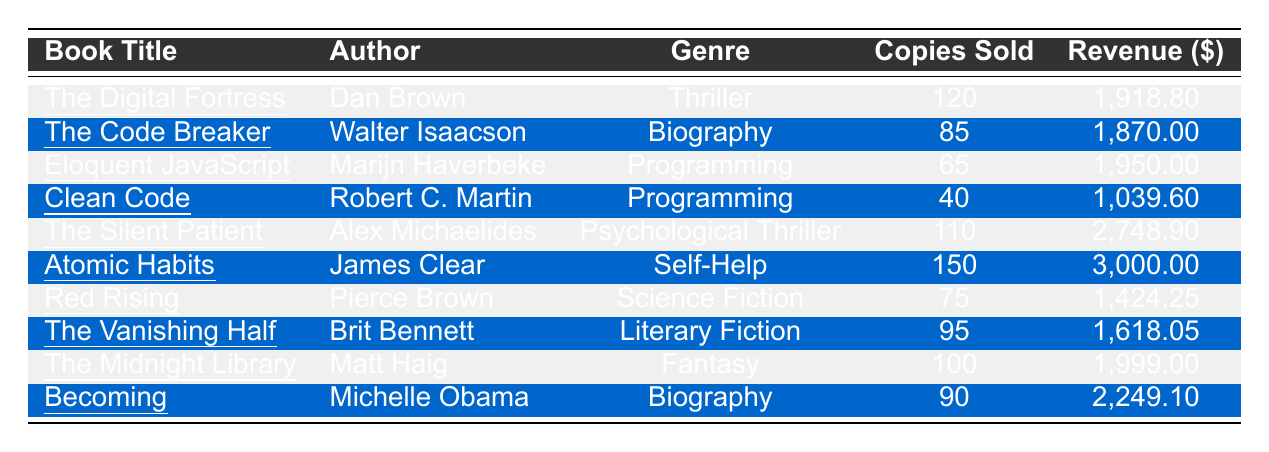What is the total revenue generated from "Atomic Habits"? The total revenue for "Atomic Habits" is listed directly in the table as $3,000.00.
Answer: 3,000.00 Which book sold the least number of copies? From the table, "Clean Code" sold 40 copies, which is the smallest number compared to the other titles.
Answer: Clean Code How many copies were sold in total for all books listed? To find the total copies sold, we need to sum the copies sold: 120 + 85 + 65 + 40 + 110 + 150 + 75 + 95 + 100 + 90 = 1030.
Answer: 1030 What is the average price per copy for all the books? We need to calculate the total revenue and the total copies sold first. Total revenue is $1,918.80 + $1,870.00 + $1,950.00 + $1,039.60 + $2,748.90 + $3,000.00 + $1,424.25 + $1,618.05 + $1,999.00 + $2,249.10 = $19,217.70. The average price is total revenue ($19,217.70) divided by total copies sold (1030) = $18.63 approximately.
Answer: 18.63 Is "Eloquent JavaScript" a part of the programming genre? Yes, the genre for "Eloquent JavaScript" is stated as programming in the table.
Answer: Yes What was the total revenue for books by Walter Isaacson? The only book by Walter Isaacson listed is "The Code Breaker" with a total revenue of $1,870.00.
Answer: 1,870.00 How many more copies were sold of "The Silent Patient" compared to "Clean Code"? "The Silent Patient" sold 110 copies and "Clean Code" sold 40 copies. The difference is 110 - 40 = 70 copies.
Answer: 70 Which genre had the highest total revenue? The total revenue for each genre needs to be summed up: "Thriller": $1,918.80, "Biography": $1,870.00 + $2,249.10 = $4,119.10, "Programming": $1,950.00 + $1,039.60 = $2,989.60, "Psychological Thriller": $2,748.90, "Self-Help": $3,000.00, "Science Fiction": $1,424.25, "Literary Fiction": $1,618.05, "Fantasy": $1,999.00. The highest is "Biography" at $4,119.10.
Answer: Biography What's the total number of copies sold for books published by Dan Brown and James Clear? Dan Brown's "The Digital Fortress" sold 120 copies, and James Clear's "Atomic Habits" sold 150 copies. The total is 120 + 150 = 270 copies.
Answer: 270 